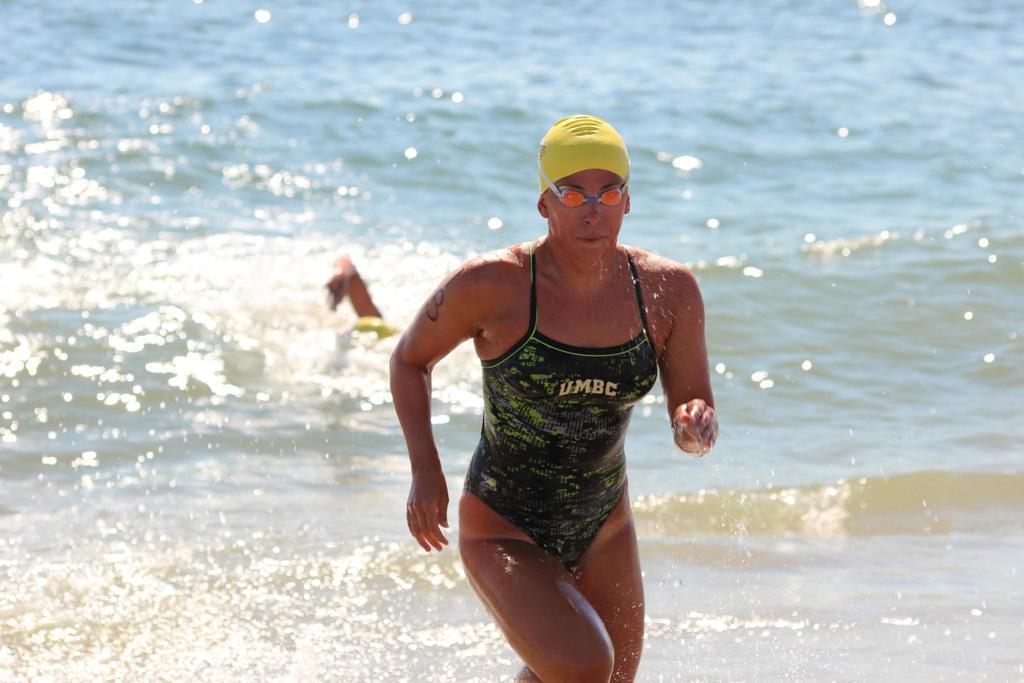Describe this image in one or two sentences. In this image I can see there is a woman in the middle running on the water and background is water, 